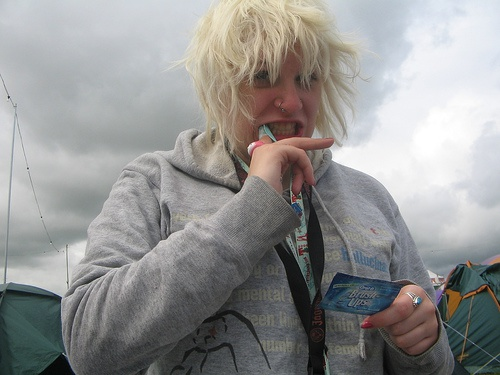Describe the objects in this image and their specific colors. I can see people in lightgray, gray, darkgray, and black tones and toothbrush in lightgray, gray, and darkgray tones in this image. 